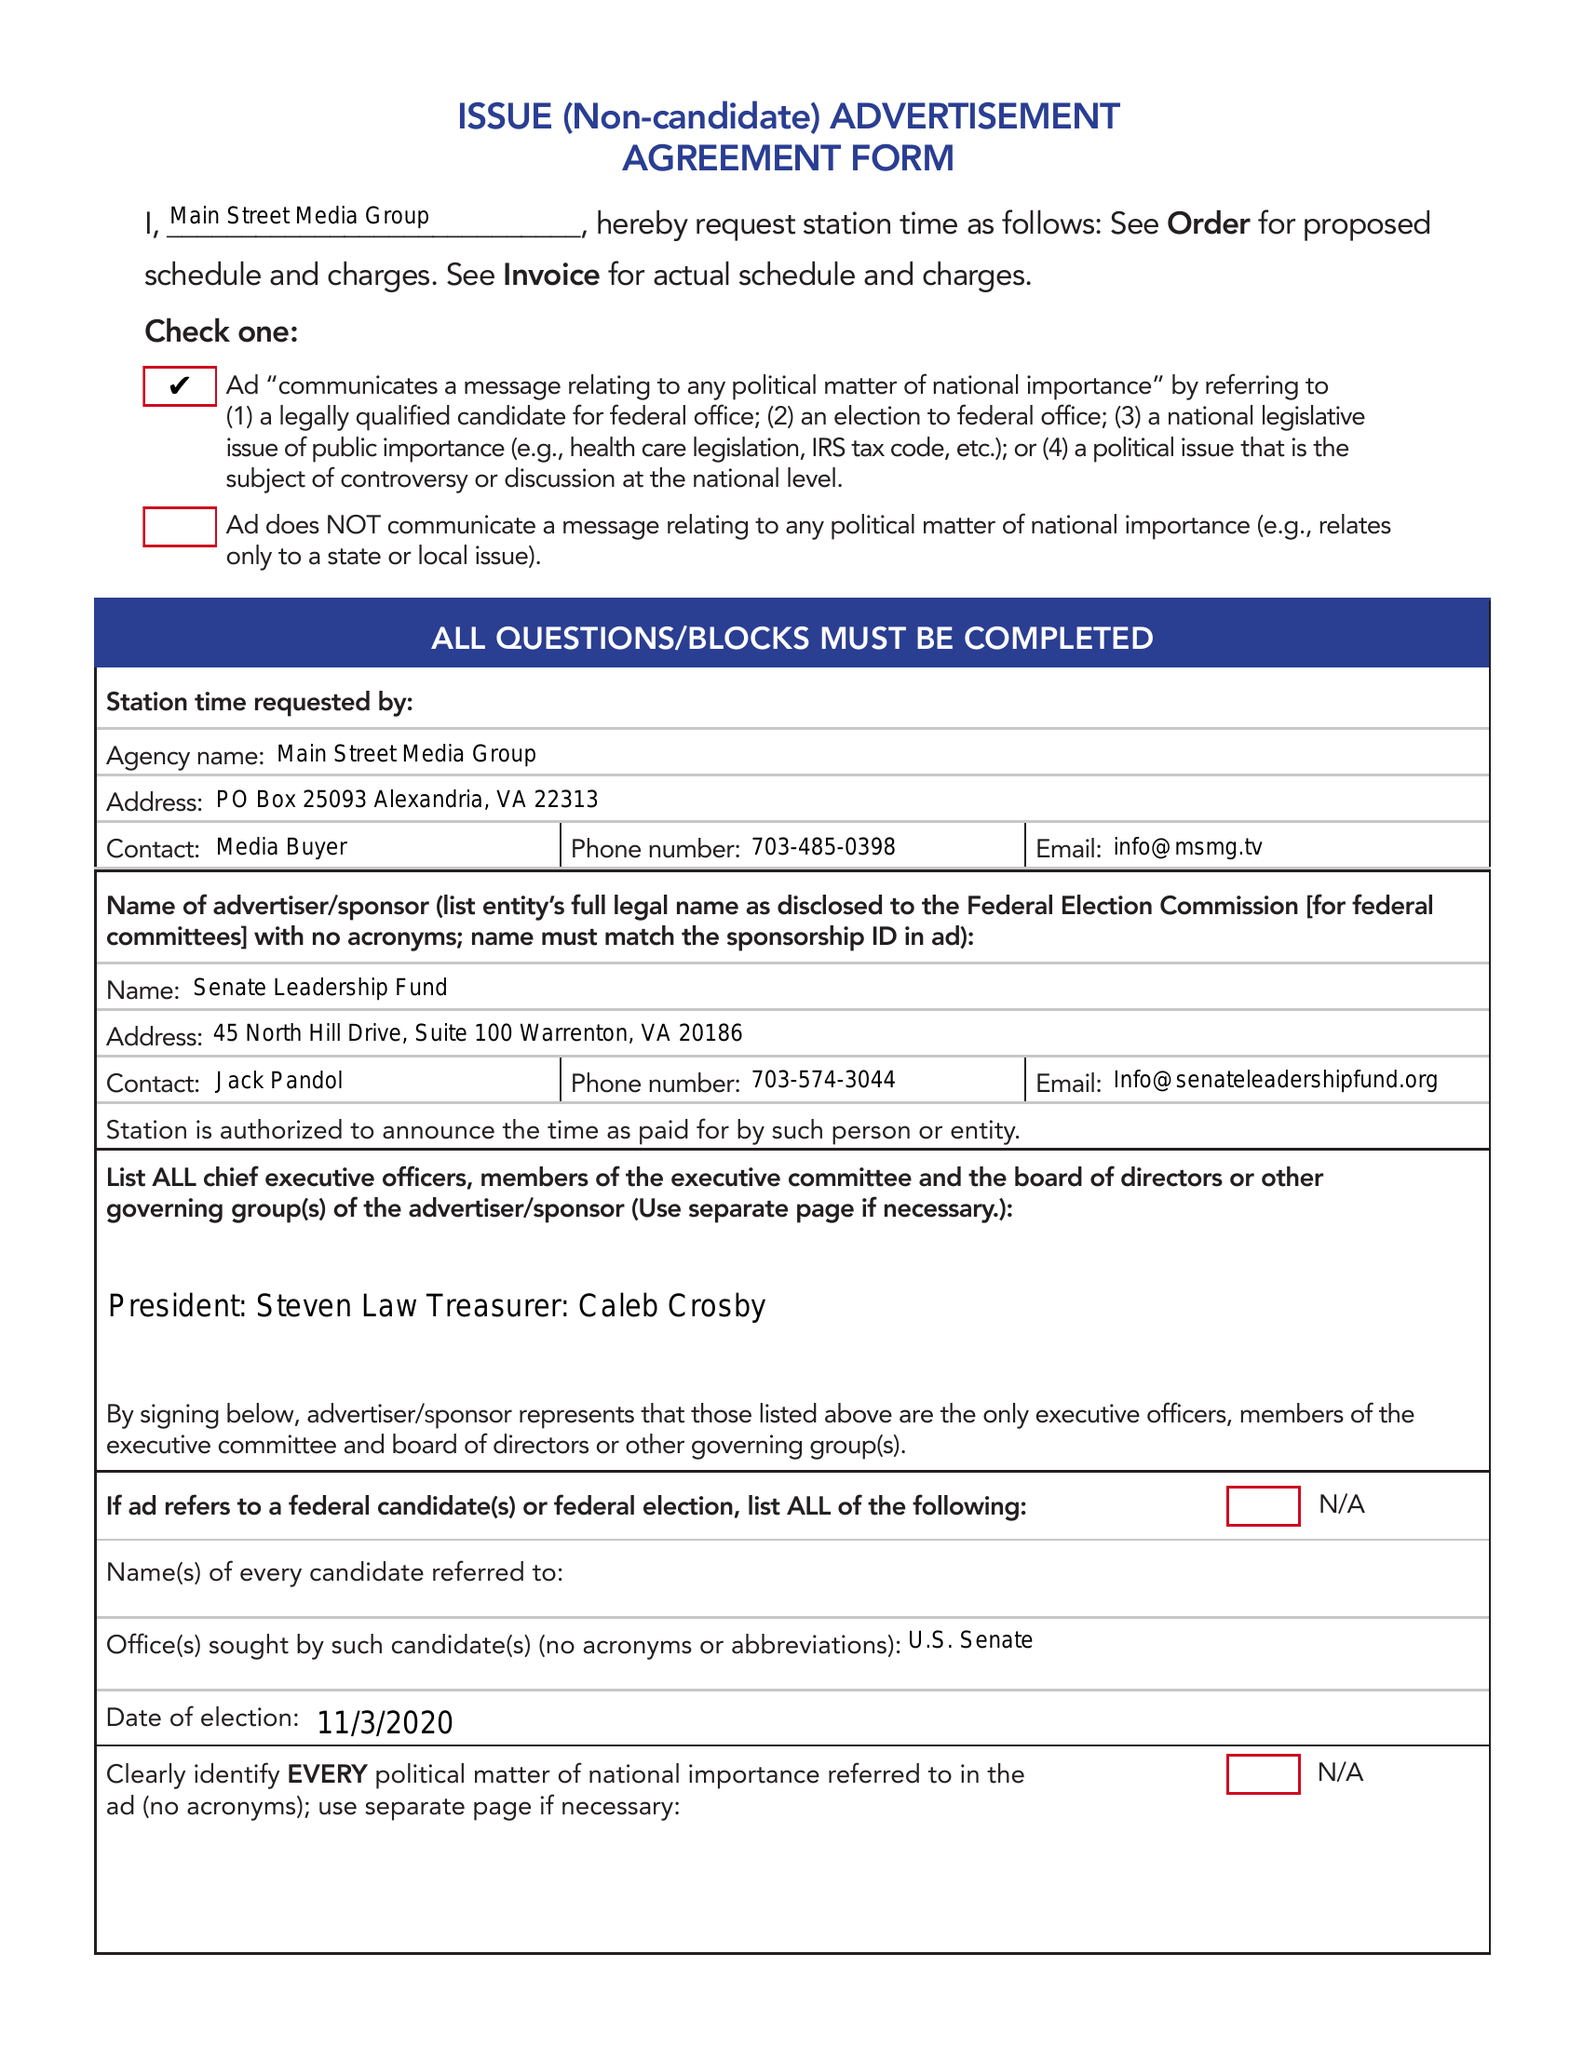What is the value for the contract_num?
Answer the question using a single word or phrase. 1563327 